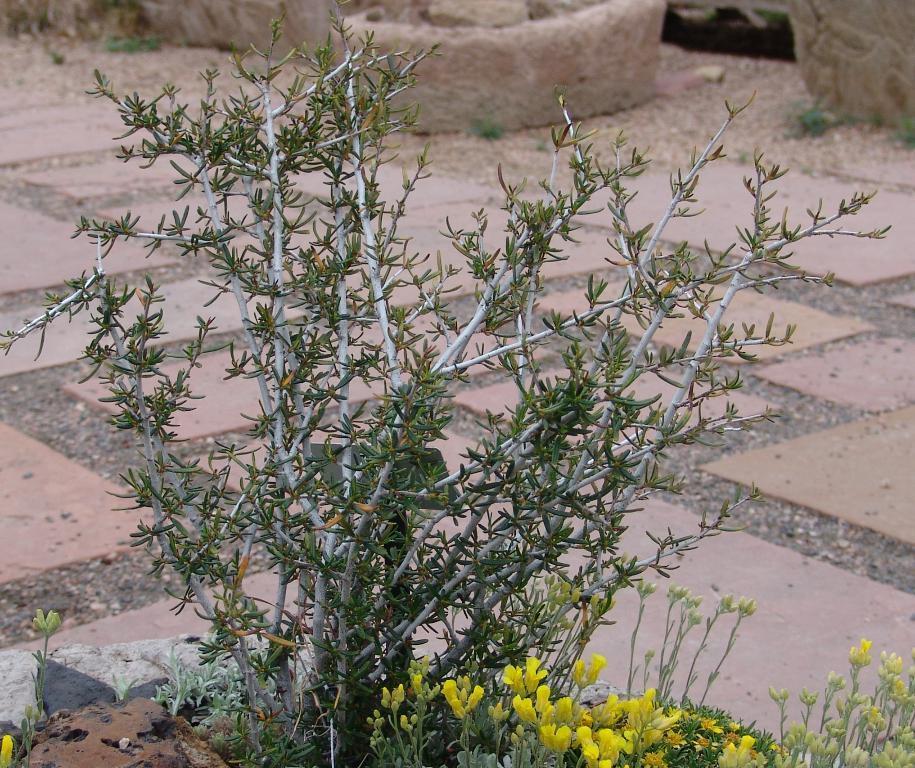How would you summarize this image in a sentence or two? In this image I see the plants over here and I see flowers which are of yellow in color. In the background I see the path and I see light brown color things over here. 